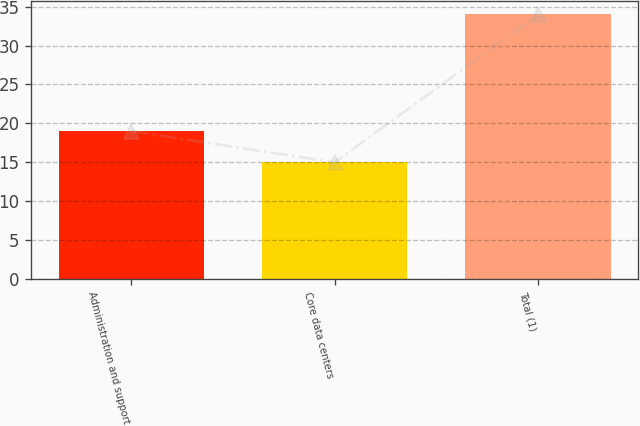Convert chart. <chart><loc_0><loc_0><loc_500><loc_500><bar_chart><fcel>Administration and support<fcel>Core data centers<fcel>Total (1)<nl><fcel>19<fcel>15<fcel>34<nl></chart> 